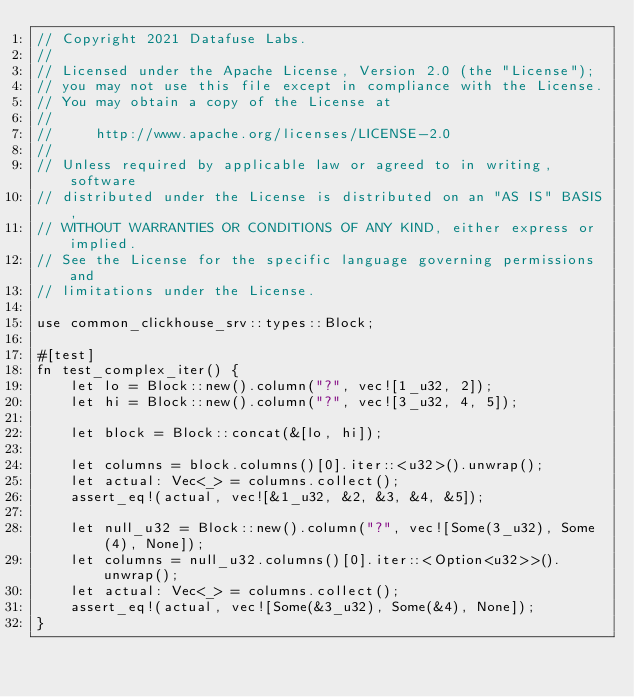<code> <loc_0><loc_0><loc_500><loc_500><_Rust_>// Copyright 2021 Datafuse Labs.
//
// Licensed under the Apache License, Version 2.0 (the "License");
// you may not use this file except in compliance with the License.
// You may obtain a copy of the License at
//
//     http://www.apache.org/licenses/LICENSE-2.0
//
// Unless required by applicable law or agreed to in writing, software
// distributed under the License is distributed on an "AS IS" BASIS,
// WITHOUT WARRANTIES OR CONDITIONS OF ANY KIND, either express or implied.
// See the License for the specific language governing permissions and
// limitations under the License.

use common_clickhouse_srv::types::Block;

#[test]
fn test_complex_iter() {
    let lo = Block::new().column("?", vec![1_u32, 2]);
    let hi = Block::new().column("?", vec![3_u32, 4, 5]);

    let block = Block::concat(&[lo, hi]);

    let columns = block.columns()[0].iter::<u32>().unwrap();
    let actual: Vec<_> = columns.collect();
    assert_eq!(actual, vec![&1_u32, &2, &3, &4, &5]);

    let null_u32 = Block::new().column("?", vec![Some(3_u32), Some(4), None]);
    let columns = null_u32.columns()[0].iter::<Option<u32>>().unwrap();
    let actual: Vec<_> = columns.collect();
    assert_eq!(actual, vec![Some(&3_u32), Some(&4), None]);
}
</code> 